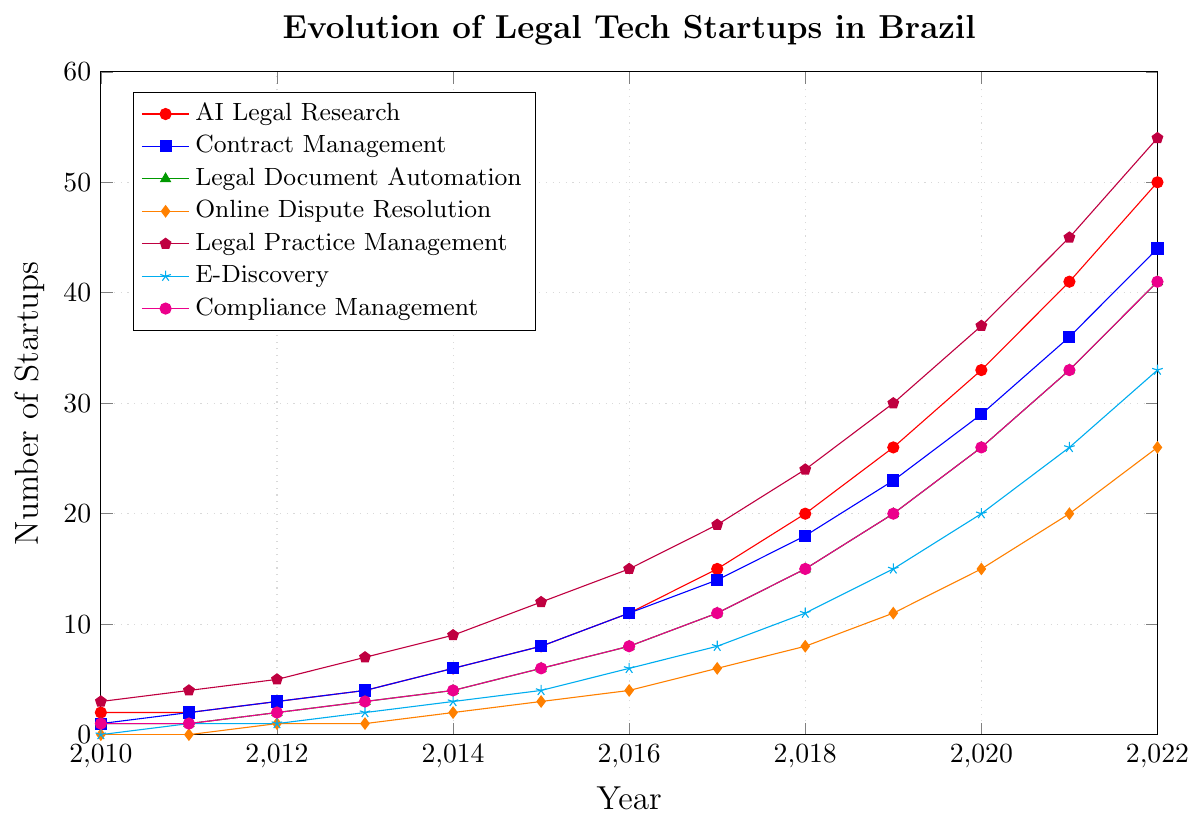Which focus area has seen the greatest increase since 2010? To determine this, look at the start and end points for each focus area and calculate the difference. AI Legal Research increased from 2 to 50, Contract Management from 1 to 44, Legal Document Automation from 1 to 41, Online Dispute Resolution from 0 to 26, Legal Practice Management from 3 to 54, E-Discovery from 0 to 33, Compliance Management from 1 to 41. Legal Practice Management has the greatest increase, from 3 to 54, which is an increase of 51.
Answer: Legal Practice Management How many startups were focused on AI Legal Research and Legal Practice Management in 2015? Look at the values for AI Legal Research and Legal Practice Management in 2015, which are 8 and 12, respectively. Sum them together: 8 + 12 = 20.
Answer: 20 By how many startups did Online Dispute Resolution grow from 2013 to 2021? Look at the values for Online Dispute Resolution in 2013 and 2021, which are 1 and 20, respectively. Subtract the earlier value from the later value: 20 - 1 = 19.
Answer: 19 Which focus area had the least number of startups in 2011 and how many were there? Inspect the values for all focus areas in 2011: AI Legal Research (2), Contract Management (2), Legal Document Automation (1), Online Dispute Resolution (0), Legal Practice Management (4), E-Discovery (1), Compliance Management (1). Online Dispute Resolution had the least number, with 0.
Answer: Online Dispute Resolution, 0 Did any focus area have the same number of startups in two consecutive years? If yes, which ones? Check the plot for any horizontal lines indicating the same value in two consecutive years. AI Legal Research had 2 startups in both 2010 and 2011. Legal Document Automation had 1 startup in both 2010 and 2011.
Answer: AI Legal Research, Legal Document Automation What is the trend for startups focused on Compliance Management from 2010 to 2022? Observe the pattern for the Compliance Management line in the plot. The number of startups consistently increases from 1 in 2010 to 41 in 2022, indicating a steady growth trend.
Answer: Increasing trend In which year did E-Discovery reach 20 startups? Locate the point where the E-Discovery line touches 20 on the y-axis. This occurs in 2020.
Answer: 2020 By how much did the number of startups for Legal Practice Management increase from 2018 to 2022? Check the values for Legal Practice Management in 2018 and 2022, which are 24 and 54, respectively. Subtract the earlier value from the later value: 54 - 24 = 30.
Answer: 30 